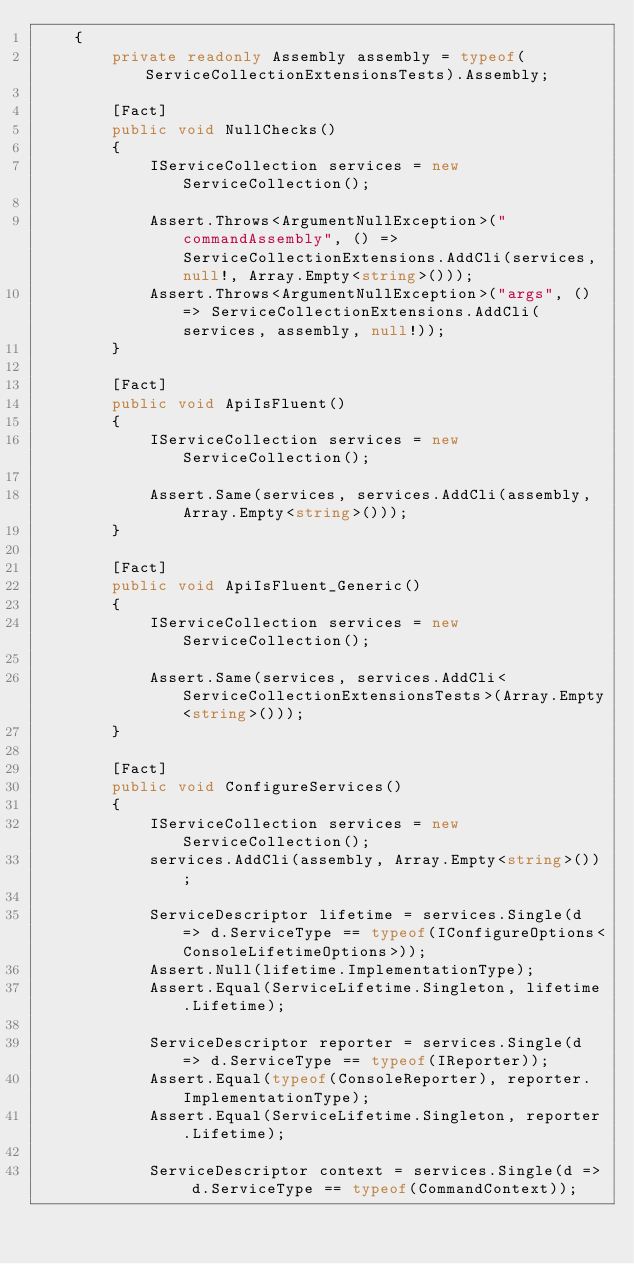Convert code to text. <code><loc_0><loc_0><loc_500><loc_500><_C#_>	{
		private readonly Assembly assembly = typeof(ServiceCollectionExtensionsTests).Assembly;

		[Fact]
		public void NullChecks()
		{
			IServiceCollection services = new ServiceCollection();

			Assert.Throws<ArgumentNullException>("commandAssembly", () => ServiceCollectionExtensions.AddCli(services, null!, Array.Empty<string>()));
			Assert.Throws<ArgumentNullException>("args", () => ServiceCollectionExtensions.AddCli(services, assembly, null!));
		}

		[Fact]
		public void ApiIsFluent()
		{
			IServiceCollection services = new ServiceCollection();

			Assert.Same(services, services.AddCli(assembly, Array.Empty<string>()));
		}

		[Fact]
		public void ApiIsFluent_Generic()
		{
			IServiceCollection services = new ServiceCollection();

			Assert.Same(services, services.AddCli<ServiceCollectionExtensionsTests>(Array.Empty<string>()));
		}

		[Fact]
		public void ConfigureServices()
		{
			IServiceCollection services = new ServiceCollection();
			services.AddCli(assembly, Array.Empty<string>());

			ServiceDescriptor lifetime = services.Single(d => d.ServiceType == typeof(IConfigureOptions<ConsoleLifetimeOptions>));
			Assert.Null(lifetime.ImplementationType);
			Assert.Equal(ServiceLifetime.Singleton, lifetime.Lifetime);

			ServiceDescriptor reporter = services.Single(d => d.ServiceType == typeof(IReporter));
			Assert.Equal(typeof(ConsoleReporter), reporter.ImplementationType);
			Assert.Equal(ServiceLifetime.Singleton, reporter.Lifetime);

			ServiceDescriptor context = services.Single(d => d.ServiceType == typeof(CommandContext));</code> 